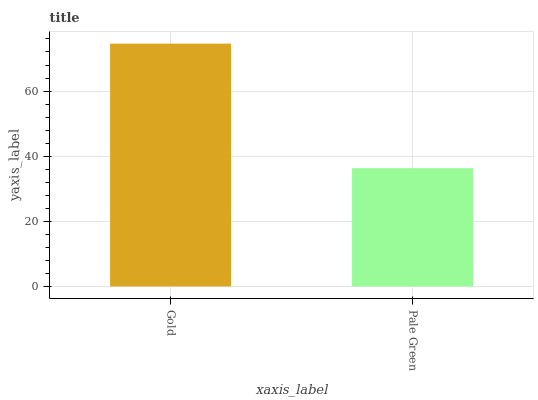Is Pale Green the minimum?
Answer yes or no. Yes. Is Gold the maximum?
Answer yes or no. Yes. Is Pale Green the maximum?
Answer yes or no. No. Is Gold greater than Pale Green?
Answer yes or no. Yes. Is Pale Green less than Gold?
Answer yes or no. Yes. Is Pale Green greater than Gold?
Answer yes or no. No. Is Gold less than Pale Green?
Answer yes or no. No. Is Gold the high median?
Answer yes or no. Yes. Is Pale Green the low median?
Answer yes or no. Yes. Is Pale Green the high median?
Answer yes or no. No. Is Gold the low median?
Answer yes or no. No. 